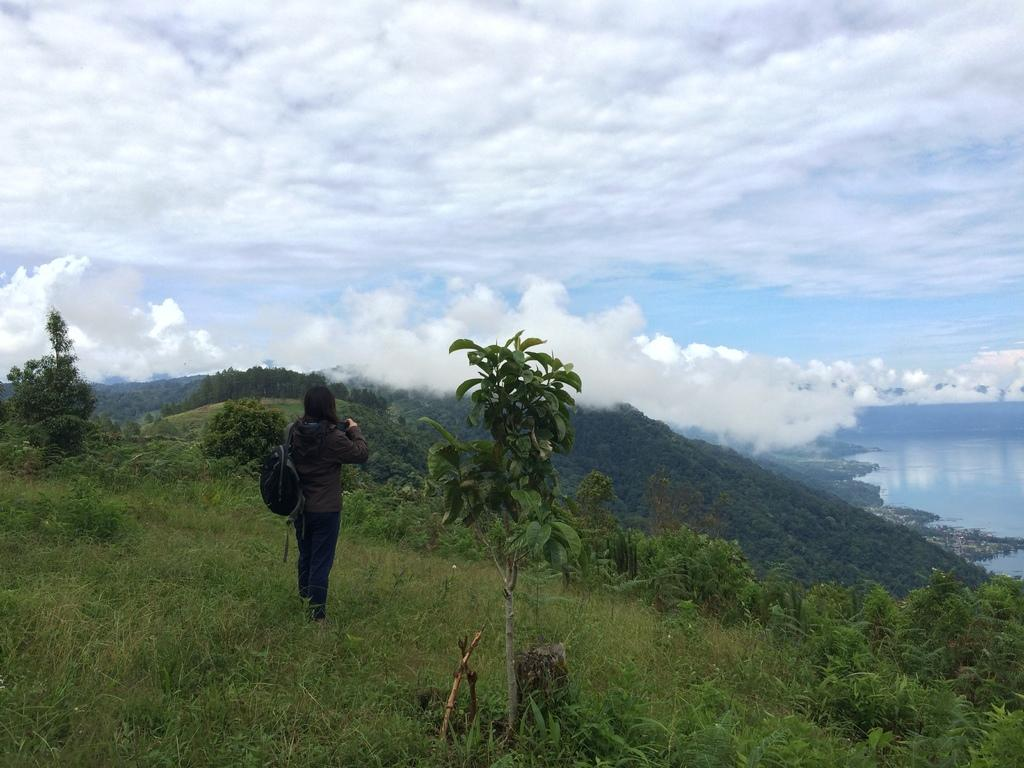What is the main subject of the image? There is a person standing in the image. What object can be seen near the person? There is a wire bag in the image. What type of natural environment is visible in the image? There is grass and plants visible in the image. What can be seen in the background of the image? There are trees and water visible in the background of the image. How would you describe the weather in the image? The sky is cloudy in the image. What type of engine is being exchanged between the person and the trees in the image? There is no engine or exchange taking place in the image; it features a person standing near a wire bag in a natural environment with trees and water in the background. 